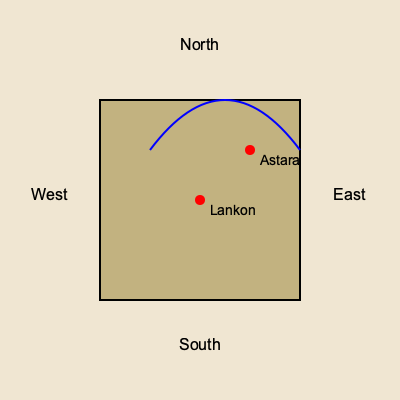Based on the historical map of the Talysh Khanate provided, which direction is the Caspian Sea in relation to the cities of Lankon and Astara? To determine the correct orientation of the historical map and identify the direction of the Caspian Sea, we need to follow these steps:

1. Identify the cardinal directions on the map:
   - North is at the top
   - East is to the right
   - South is at the bottom
   - West is to the left

2. Locate the cities on the map:
   - Lankon is represented by the red dot in the center
   - Astara is represented by the red dot to the northeast of Lankon

3. Analyze the geographical features:
   - The blue curved line at the top of the map represents a coastline

4. Apply historical knowledge of the Talysh Khanate:
   - The Talysh Khanate was located along the southwestern coast of the Caspian Sea
   - Lankon (modern-day Lankaran) and Astara are coastal cities on the Caspian Sea

5. Conclude the orientation:
   - Given that the coastline is to the east of the cities, and knowing that these cities are on the Caspian Sea coast, we can determine that the Caspian Sea is to the east of Lankon and Astara on this map.
Answer: East 